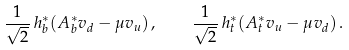<formula> <loc_0><loc_0><loc_500><loc_500>\frac { 1 } { \sqrt { 2 } } \, h _ { b } ^ { * } ( A _ { b } ^ { * } v _ { d } - \mu v _ { u } ) \, , \quad \frac { 1 } { \sqrt { 2 } } \, h _ { t } ^ { * } ( A _ { t } ^ { * } v _ { u } - \mu v _ { d } ) \, .</formula> 